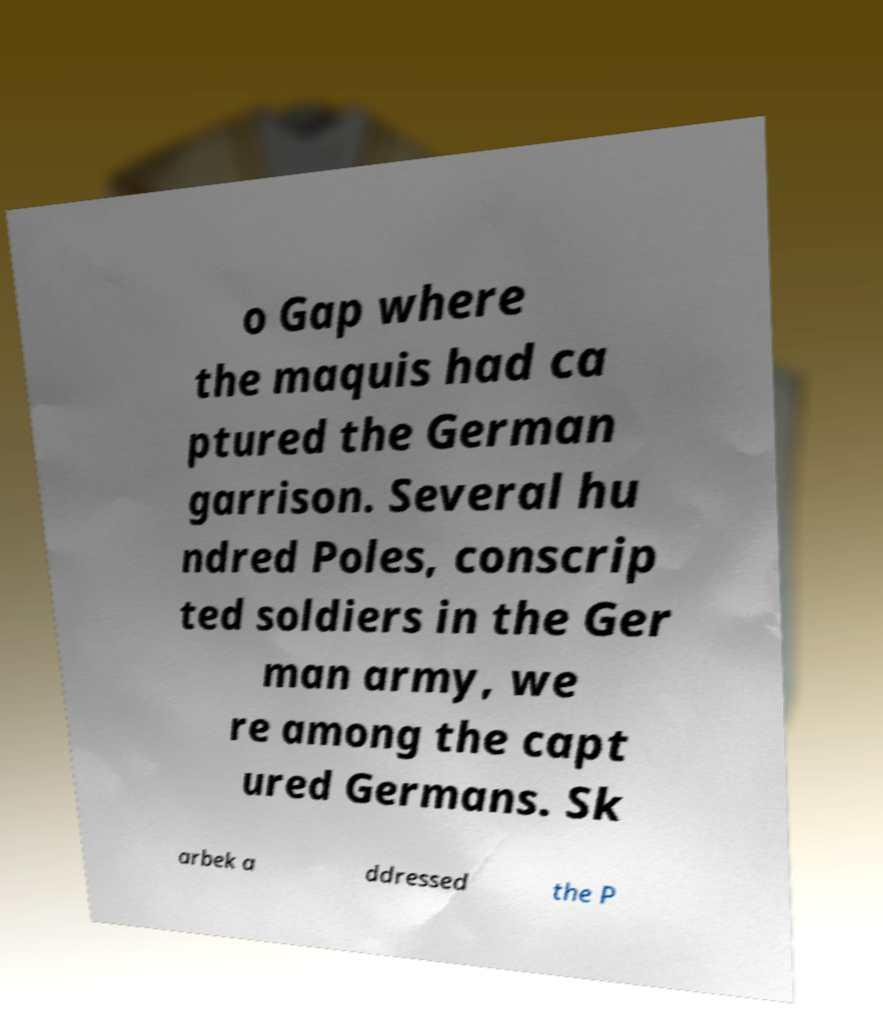I need the written content from this picture converted into text. Can you do that? o Gap where the maquis had ca ptured the German garrison. Several hu ndred Poles, conscrip ted soldiers in the Ger man army, we re among the capt ured Germans. Sk arbek a ddressed the P 